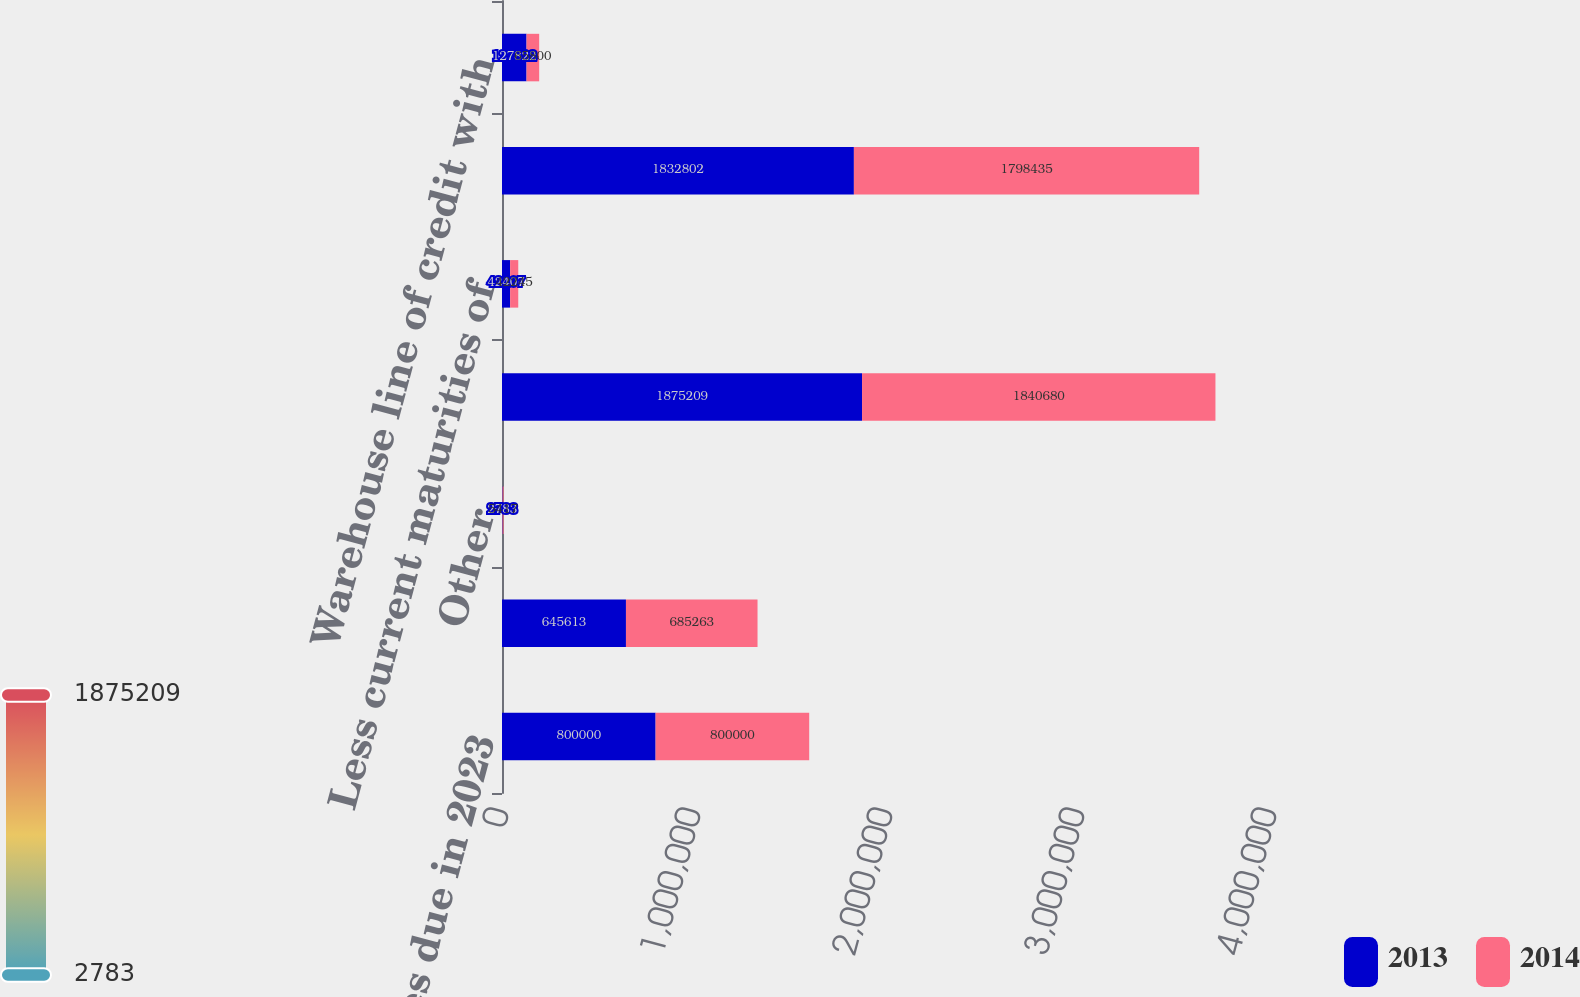Convert chart. <chart><loc_0><loc_0><loc_500><loc_500><stacked_bar_chart><ecel><fcel>500 senior notes due in 2023<fcel>Senior secured term loans with<fcel>Other<fcel>Subtotal<fcel>Less current maturities of<fcel>Total long-term debt<fcel>Warehouse line of credit with<nl><fcel>2013<fcel>800000<fcel>645613<fcel>2783<fcel>1.87521e+06<fcel>42407<fcel>1.8328e+06<fcel>127822<nl><fcel>2014<fcel>800000<fcel>685263<fcel>5417<fcel>1.84068e+06<fcel>42245<fcel>1.79844e+06<fcel>65800<nl></chart> 